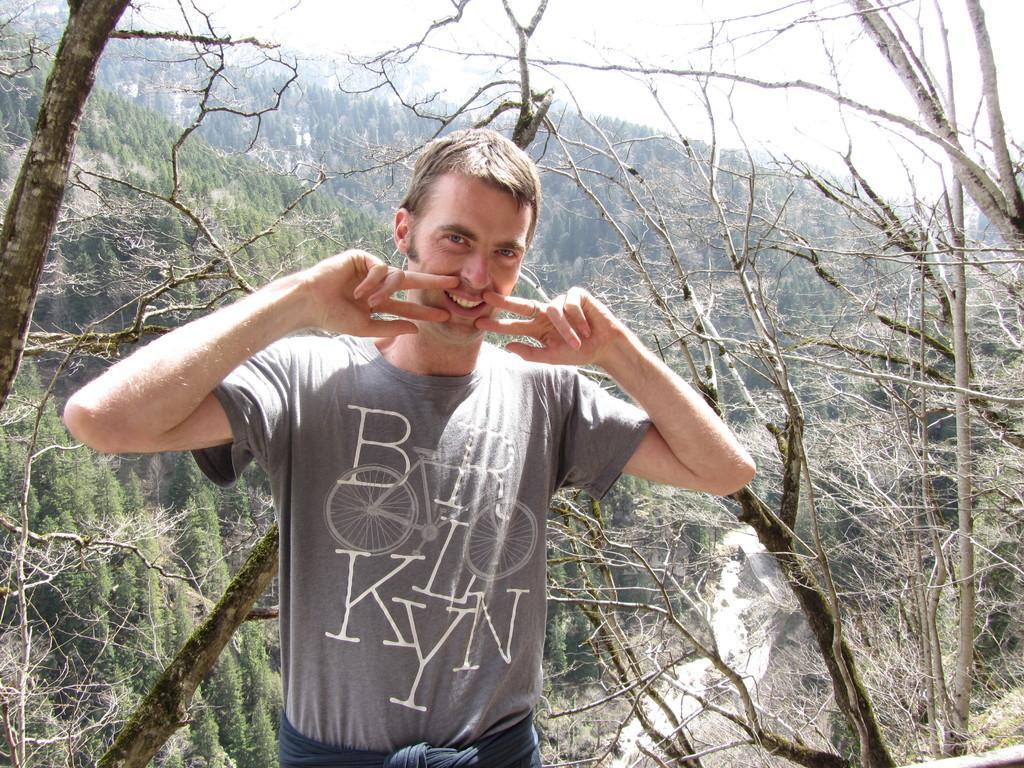How would you summarize this image in a sentence or two? In this image we can see a man standing. On the backside we can see a group of trees, some branches of the trees and the sky. 